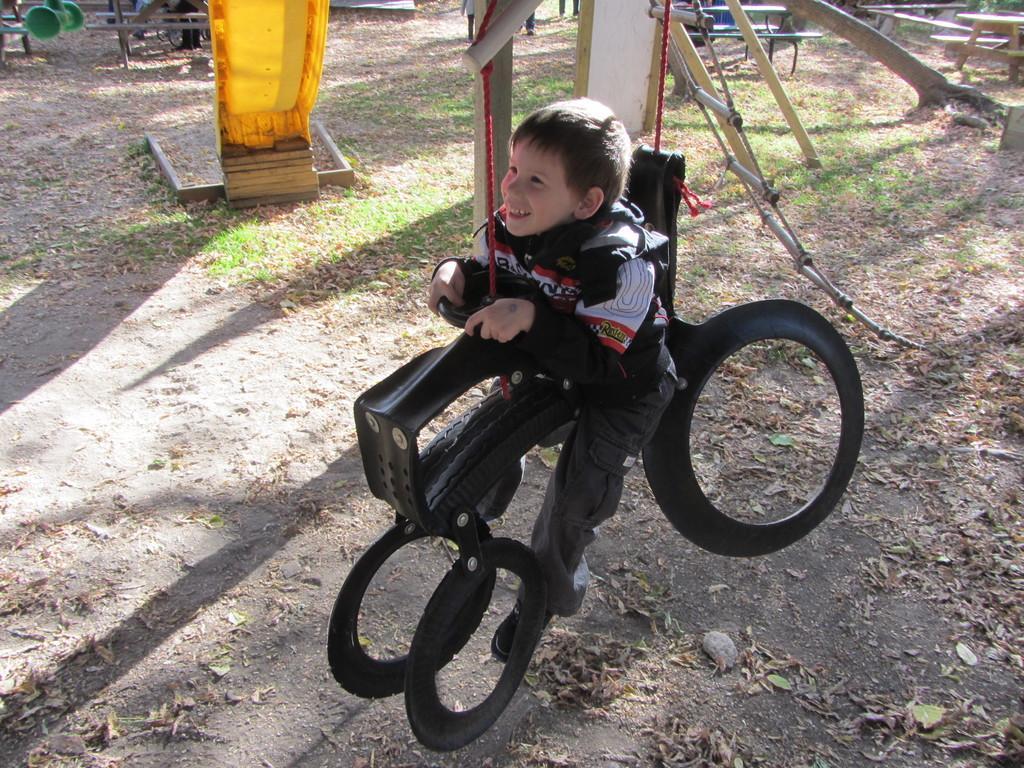Describe this image in one or two sentences. In this image I can see a boy is sitting on a toy and playing a game. In the background I can see metal rods, grass, poles and so on. This image is taken during a day. 